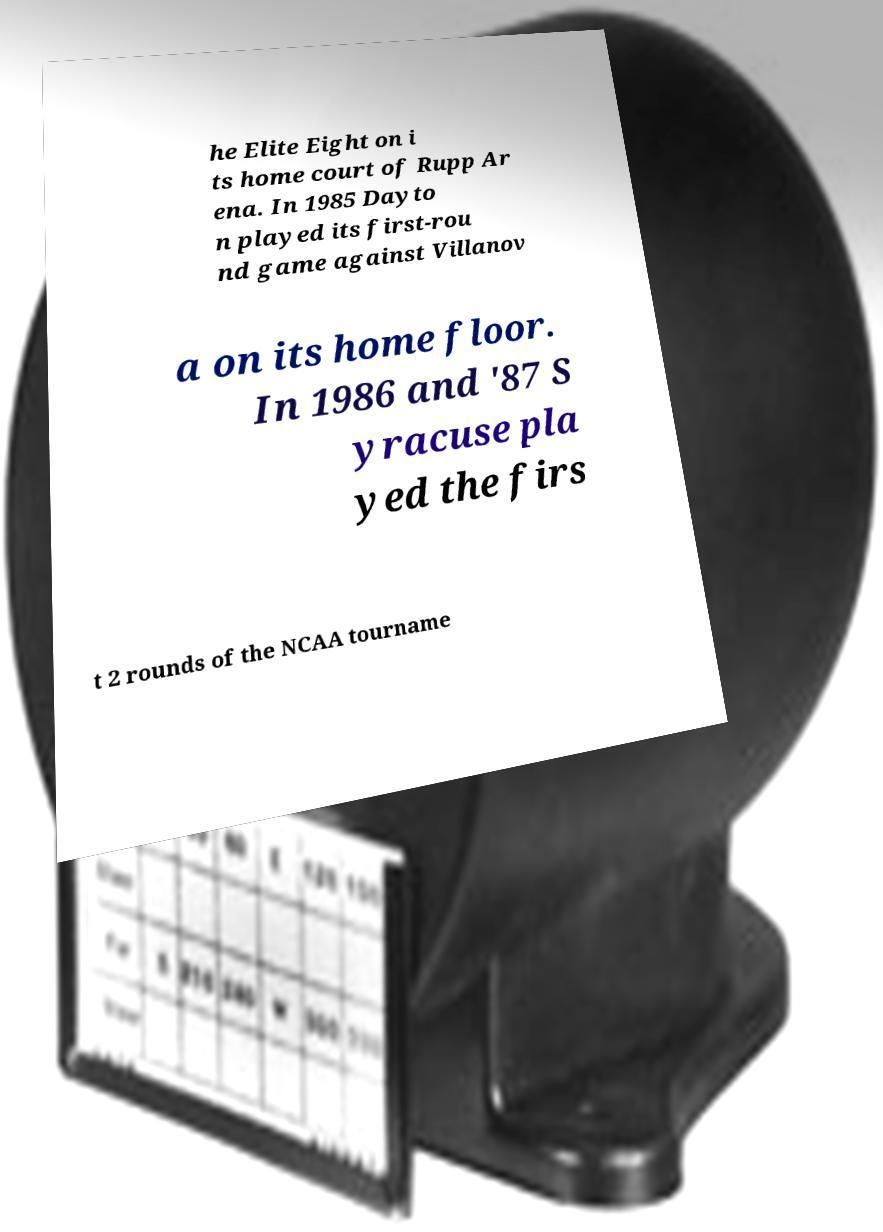What messages or text are displayed in this image? I need them in a readable, typed format. he Elite Eight on i ts home court of Rupp Ar ena. In 1985 Dayto n played its first-rou nd game against Villanov a on its home floor. In 1986 and '87 S yracuse pla yed the firs t 2 rounds of the NCAA tourname 